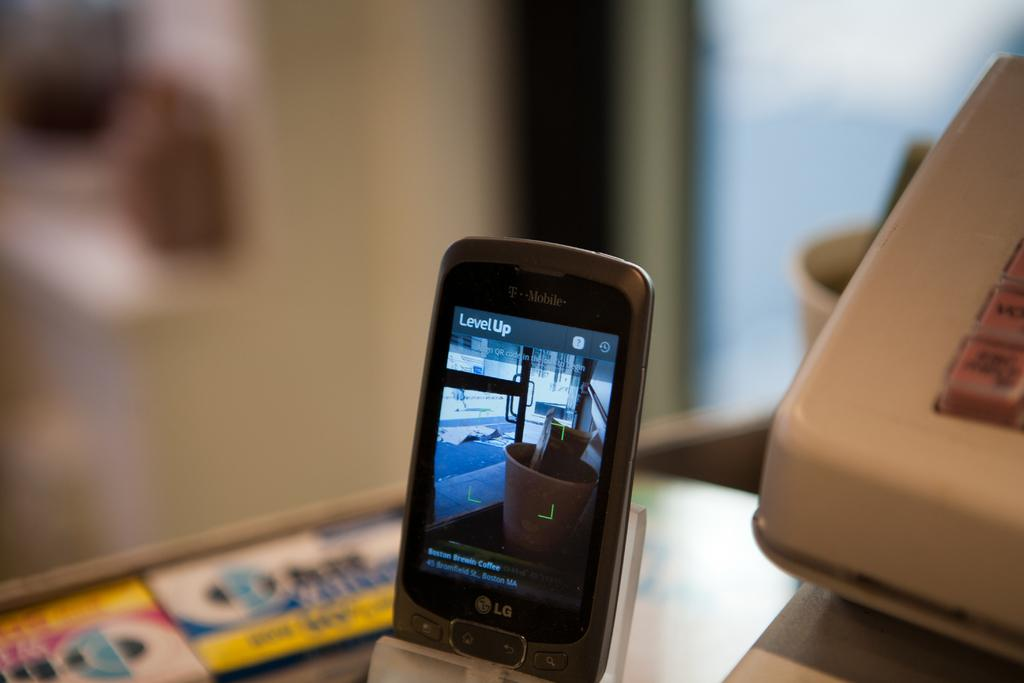<image>
Relay a brief, clear account of the picture shown. A smartphone with LevelUp on the screen is in a holder on a table. 